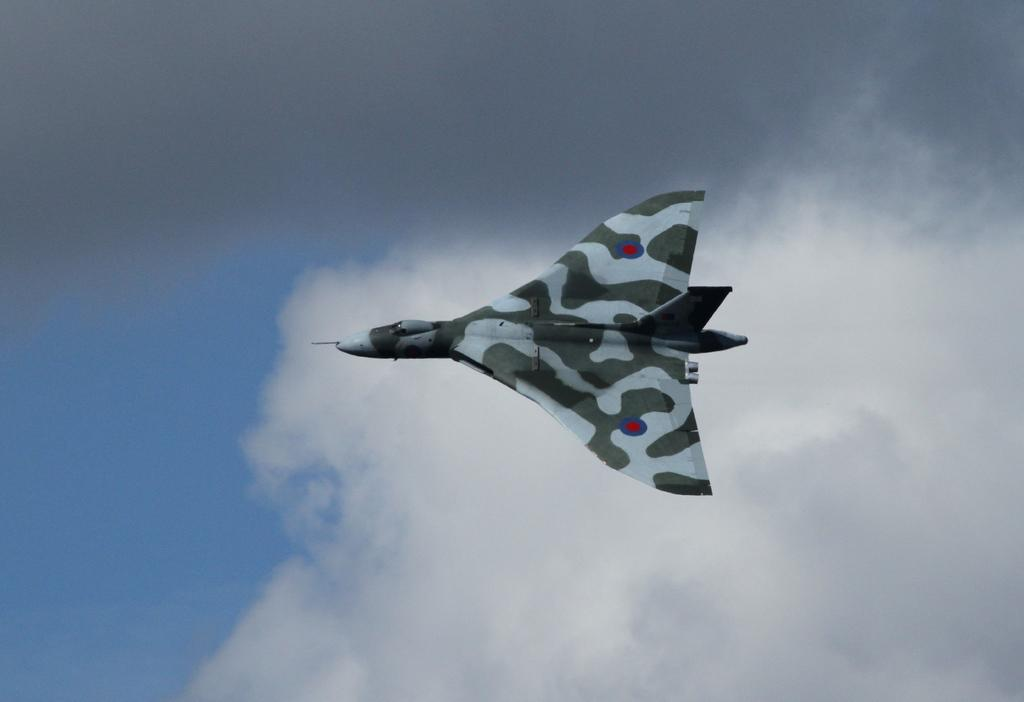What type of aircraft is in the image? There is a military aircraft in the image. Where is the aircraft located in the image? The aircraft is flying in the sky. How many flowers can be seen growing on the twig in the image? There are no flowers or twigs present in the image; it features a military aircraft flying in the sky. 